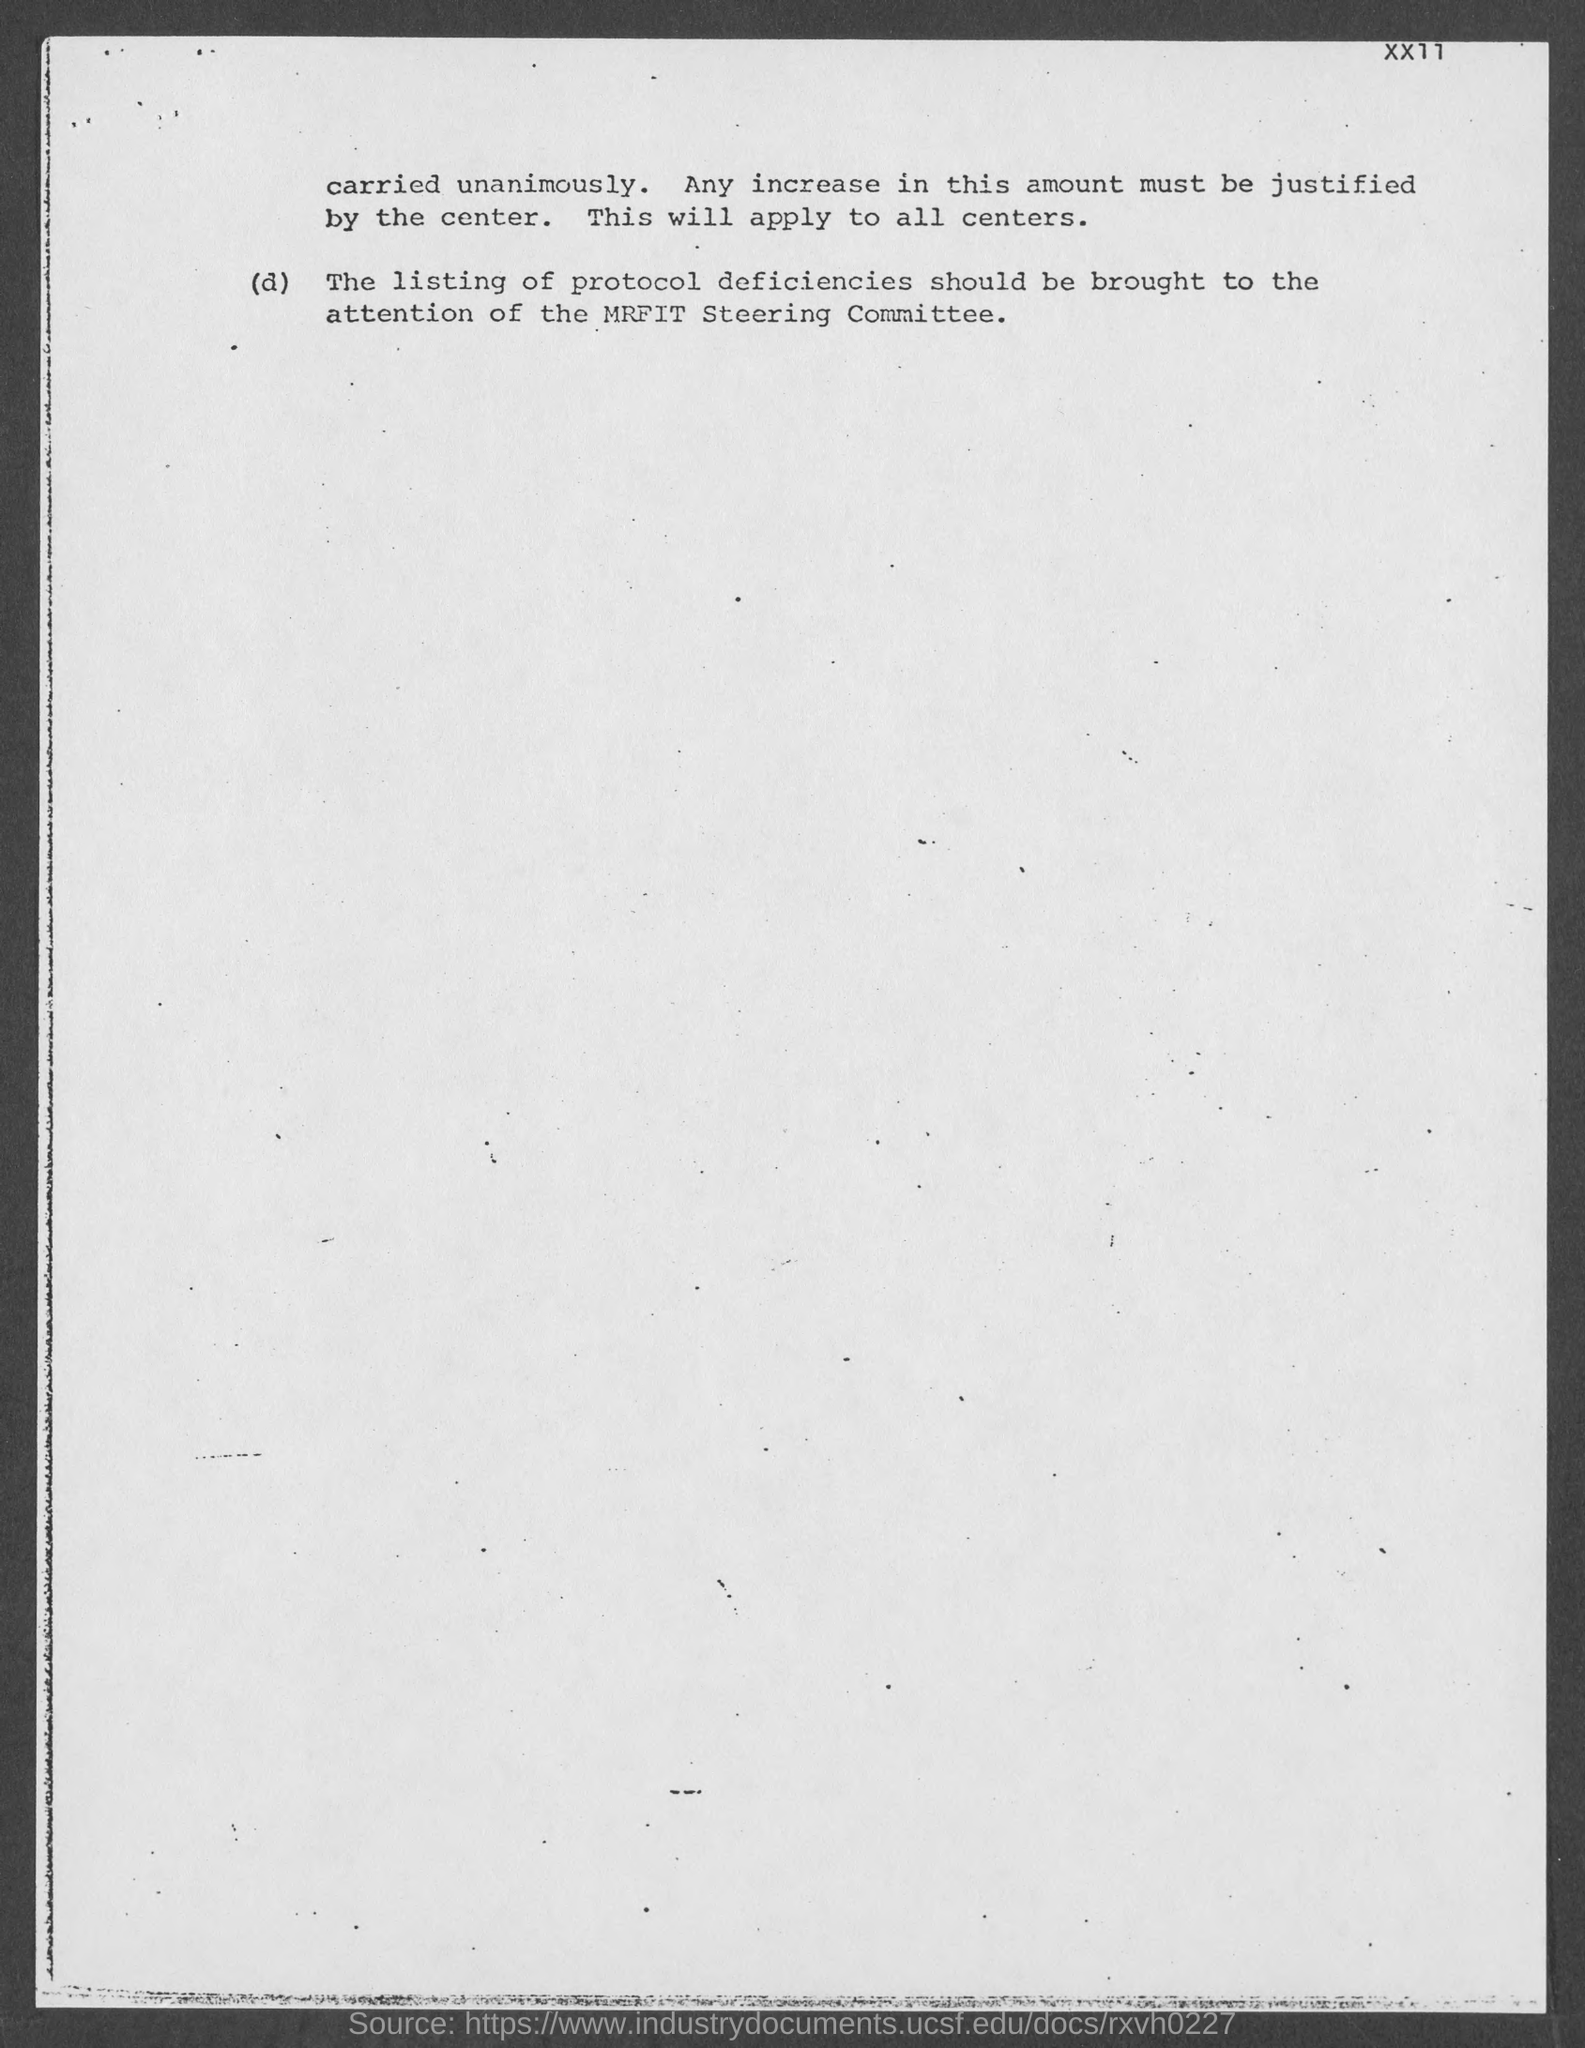Mention a couple of crucial points in this snapshot. The MRFIT Steering Committee is responsible for addressing protocol deficiencies. 